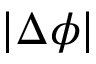Convert formula to latex. <formula><loc_0><loc_0><loc_500><loc_500>| \Delta \phi |</formula> 